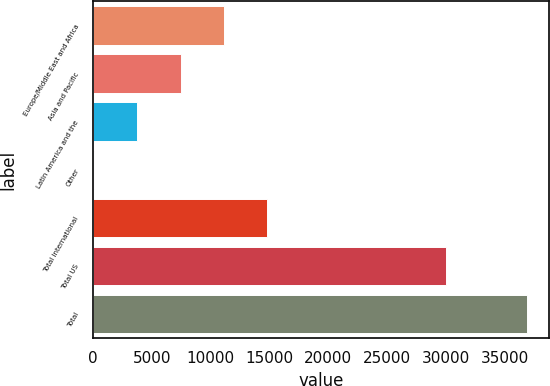Convert chart. <chart><loc_0><loc_0><loc_500><loc_500><bar_chart><fcel>Europe/Middle East and Africa<fcel>Asia and Pacific<fcel>Latin America and the<fcel>Other<fcel>Total international<fcel>Total US<fcel>Total<nl><fcel>11124.8<fcel>7442.2<fcel>3759.6<fcel>77<fcel>14807.4<fcel>30014<fcel>36903<nl></chart> 